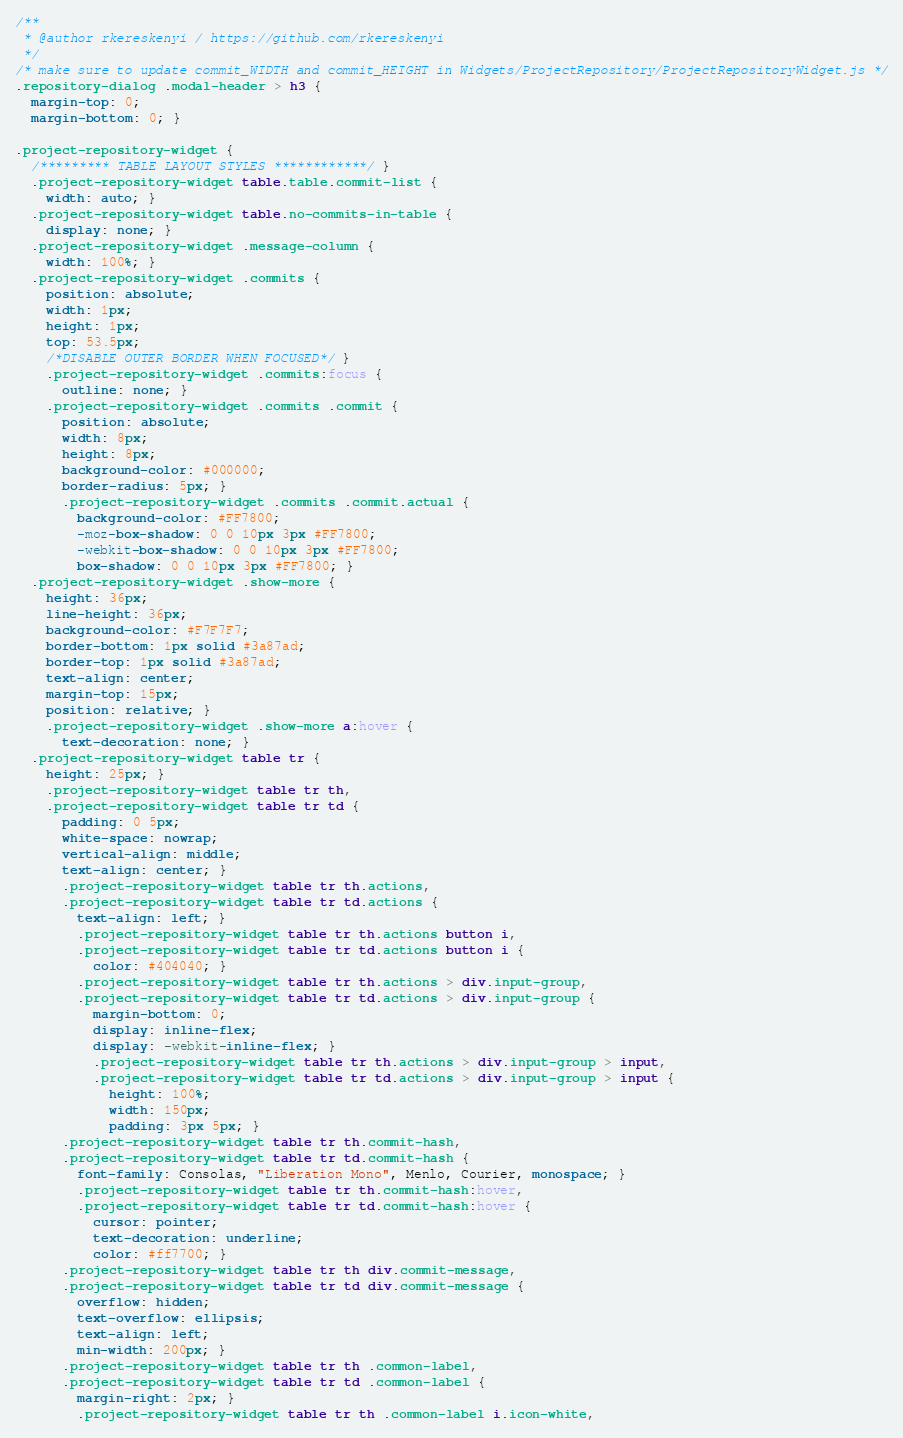Convert code to text. <code><loc_0><loc_0><loc_500><loc_500><_CSS_>/**
 * @author rkereskenyi / https://github.com/rkereskenyi
 */
/* make sure to update commit_WIDTH and commit_HEIGHT in Widgets/ProjectRepository/ProjectRepositoryWidget.js */
.repository-dialog .modal-header > h3 {
  margin-top: 0;
  margin-bottom: 0; }

.project-repository-widget {
  /********* TABLE LAYOUT STYLES ************/ }
  .project-repository-widget table.table.commit-list {
    width: auto; }
  .project-repository-widget table.no-commits-in-table {
    display: none; }
  .project-repository-widget .message-column {
    width: 100%; }
  .project-repository-widget .commits {
    position: absolute;
    width: 1px;
    height: 1px;
    top: 53.5px;
    /*DISABLE OUTER BORDER WHEN FOCUSED*/ }
    .project-repository-widget .commits:focus {
      outline: none; }
    .project-repository-widget .commits .commit {
      position: absolute;
      width: 8px;
      height: 8px;
      background-color: #000000;
      border-radius: 5px; }
      .project-repository-widget .commits .commit.actual {
        background-color: #FF7800;
        -moz-box-shadow: 0 0 10px 3px #FF7800;
        -webkit-box-shadow: 0 0 10px 3px #FF7800;
        box-shadow: 0 0 10px 3px #FF7800; }
  .project-repository-widget .show-more {
    height: 36px;
    line-height: 36px;
    background-color: #F7F7F7;
    border-bottom: 1px solid #3a87ad;
    border-top: 1px solid #3a87ad;
    text-align: center;
    margin-top: 15px;
    position: relative; }
    .project-repository-widget .show-more a:hover {
      text-decoration: none; }
  .project-repository-widget table tr {
    height: 25px; }
    .project-repository-widget table tr th,
    .project-repository-widget table tr td {
      padding: 0 5px;
      white-space: nowrap;
      vertical-align: middle;
      text-align: center; }
      .project-repository-widget table tr th.actions,
      .project-repository-widget table tr td.actions {
        text-align: left; }
        .project-repository-widget table tr th.actions button i,
        .project-repository-widget table tr td.actions button i {
          color: #404040; }
        .project-repository-widget table tr th.actions > div.input-group,
        .project-repository-widget table tr td.actions > div.input-group {
          margin-bottom: 0;
          display: inline-flex;
          display: -webkit-inline-flex; }
          .project-repository-widget table tr th.actions > div.input-group > input,
          .project-repository-widget table tr td.actions > div.input-group > input {
            height: 100%;
            width: 150px;
            padding: 3px 5px; }
      .project-repository-widget table tr th.commit-hash,
      .project-repository-widget table tr td.commit-hash {
        font-family: Consolas, "Liberation Mono", Menlo, Courier, monospace; }
        .project-repository-widget table tr th.commit-hash:hover,
        .project-repository-widget table tr td.commit-hash:hover {
          cursor: pointer;
          text-decoration: underline;
          color: #ff7700; }
      .project-repository-widget table tr th div.commit-message,
      .project-repository-widget table tr td div.commit-message {
        overflow: hidden;
        text-overflow: ellipsis;
        text-align: left;
        min-width: 200px; }
      .project-repository-widget table tr th .common-label,
      .project-repository-widget table tr td .common-label {
        margin-right: 2px; }
        .project-repository-widget table tr th .common-label i.icon-white,</code> 